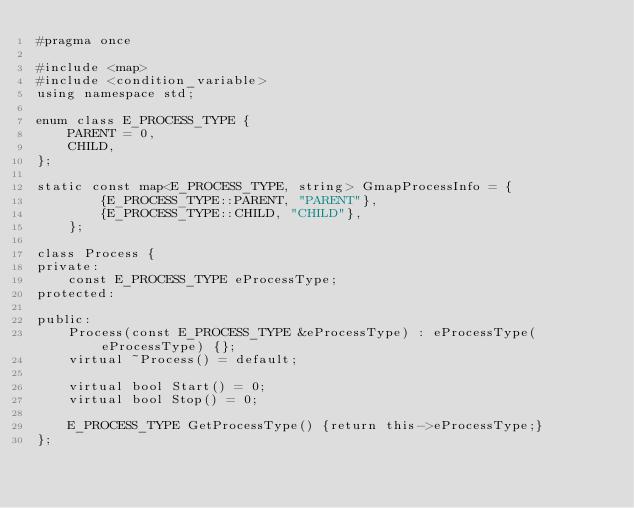Convert code to text. <code><loc_0><loc_0><loc_500><loc_500><_C_>#pragma once

#include <map>
#include <condition_variable>
using namespace std;

enum class E_PROCESS_TYPE {
	PARENT = 0,
	CHILD,
};

static const map<E_PROCESS_TYPE, string> GmapProcessInfo = {
		{E_PROCESS_TYPE::PARENT, "PARENT"},
		{E_PROCESS_TYPE::CHILD, "CHILD"},
	};

class Process {
private:
	const E_PROCESS_TYPE eProcessType;
protected:

public:
	Process(const E_PROCESS_TYPE &eProcessType) : eProcessType(eProcessType) {};
	virtual ~Process() = default;

	virtual bool Start() = 0;
	virtual bool Stop() = 0;

	E_PROCESS_TYPE GetProcessType() {return this->eProcessType;}
};
</code> 